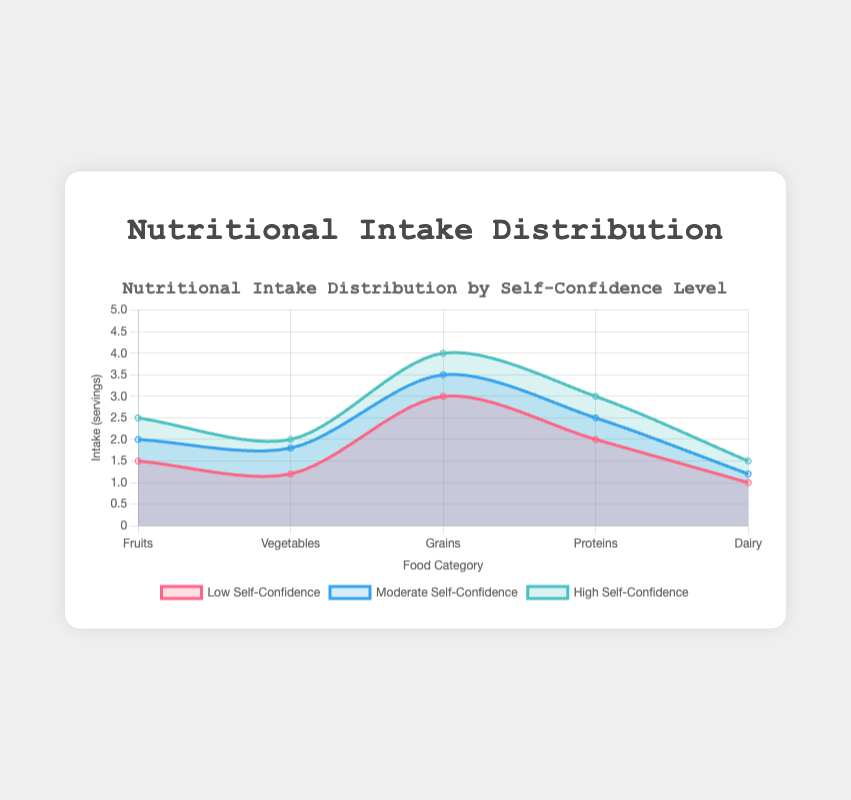What is the title of the chart? Look at the top of the chart where the title is displayed, it reads "Nutritional Intake Distribution by Self-Confidence Level".
Answer: Nutritional Intake Distribution by Self-Confidence Level How many categories of food are displayed in the chart? Observe the x-axis, which lists the categories of food. They are Fruits, Vegetables, Grains, Proteins, Dairy. Counting these categories gives five.
Answer: 5 Which self-confidence level has the highest intake for Vegetables? Compare the intake values for Vegetables for Low (1.2), Moderate (1.8), and High (2.0) self-confidence levels, and see that High has the highest intake.
Answer: High How much greater is the intake of Grains for students with High self-confidence compared to those with Low self-confidence? Look at the intake values for Grains for High (4.0) and Low (3.0) self-confidence, and calculate the difference: 4.0 - 3.0 = 1.0
Answer: 1.0 Which category of food sees a consistent increase in intake as self-confidence levels go from Low to High? Observe all categories and note their intake values for Low, Moderate, and High. Fruits show increases across all levels: Low (1.5), Moderate (2.0), High (2.5).
Answer: Fruits What is the average intake of Proteins across all self-confidence levels? Add the intake values for Proteins for all self-confidence levels: 2.0 (Low) + 2.5 (Moderate) + 3.0 (High) = 7.5. Then, divide by the number of levels: 7.5/3 = 2.5
Answer: 2.5 Which self-confidence level generally has the highest intake across all food categories? By visually comparing the areas under each segment, High self-confidence tends to have the highest intake values across most categories.
Answer: High What is the intake difference for Dairy between Low and Moderate self-confidence levels? Compare the intake values for Dairy for Low (1.0) and Moderate (1.2) self-confidence levels and calculate the difference: 1.2 - 1.0 = 0.2
Answer: 0.2 What is the total intake of all food categories for students with Low self-confidence? Sum the intake values for all categories for Low self-confidence: 1.5 (Fruits) + 1.2 (Vegetables) + 3.0 (Grains) + 2.0 (Proteins) + 1.0 (Dairy) = 8.7
Answer: 8.7 How does the intake of Dairy compare between students with Moderate and High self-confidence levels? Observe the intake values for Dairy for Moderate (1.2) and High (1.5) self-confidence levels and compare them; 1.5 is greater than 1.2.
Answer: Higher in High 